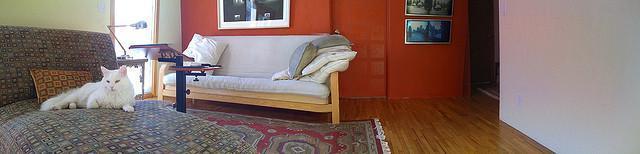How many sheep are laying in the grass?
Give a very brief answer. 0. 